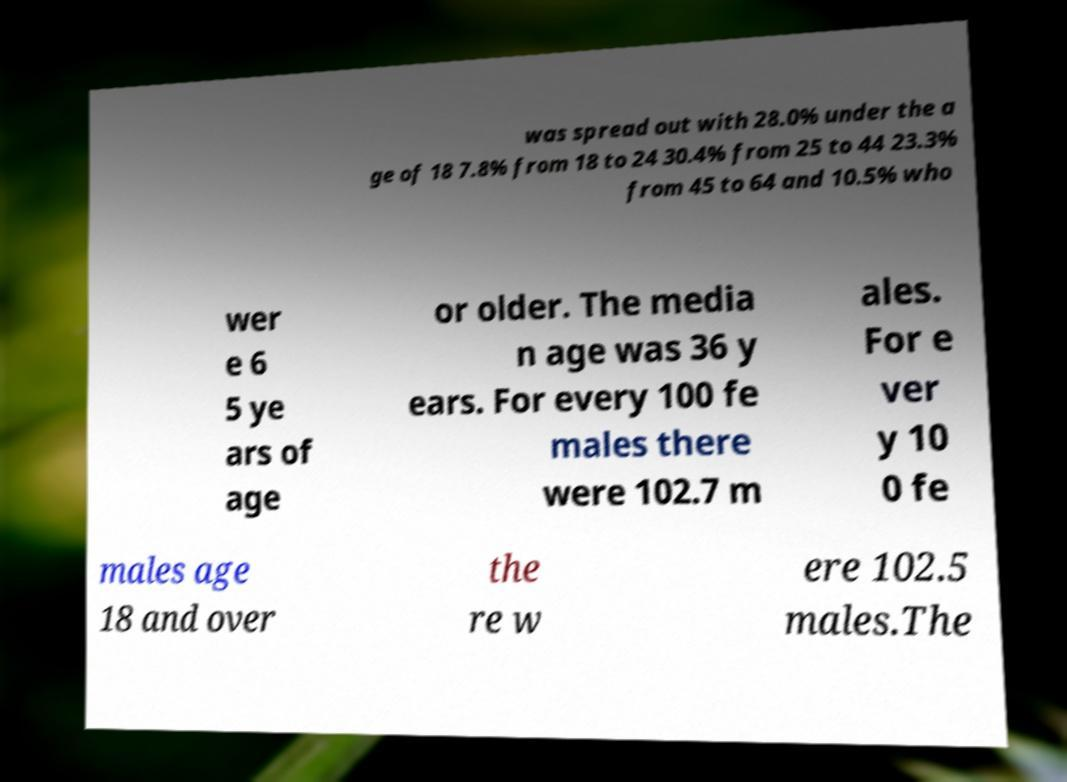I need the written content from this picture converted into text. Can you do that? was spread out with 28.0% under the a ge of 18 7.8% from 18 to 24 30.4% from 25 to 44 23.3% from 45 to 64 and 10.5% who wer e 6 5 ye ars of age or older. The media n age was 36 y ears. For every 100 fe males there were 102.7 m ales. For e ver y 10 0 fe males age 18 and over the re w ere 102.5 males.The 